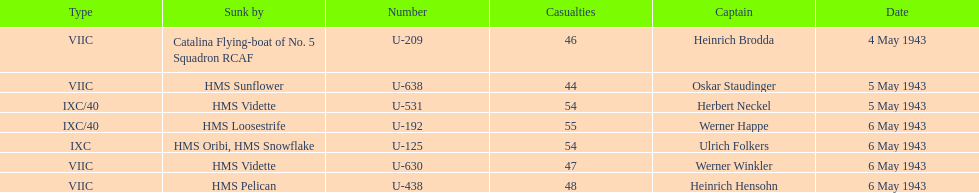Which sunken u-boat had the most casualties U-192. Could you parse the entire table? {'header': ['Type', 'Sunk by', 'Number', 'Casualties', 'Captain', 'Date'], 'rows': [['VIIC', 'Catalina Flying-boat of No. 5 Squadron RCAF', 'U-209', '46', 'Heinrich Brodda', '4 May 1943'], ['VIIC', 'HMS Sunflower', 'U-638', '44', 'Oskar Staudinger', '5 May 1943'], ['IXC/40', 'HMS Vidette', 'U-531', '54', 'Herbert Neckel', '5 May 1943'], ['IXC/40', 'HMS Loosestrife', 'U-192', '55', 'Werner Happe', '6 May 1943'], ['IXC', 'HMS Oribi, HMS Snowflake', 'U-125', '54', 'Ulrich Folkers', '6 May 1943'], ['VIIC', 'HMS Vidette', 'U-630', '47', 'Werner Winkler', '6 May 1943'], ['VIIC', 'HMS Pelican', 'U-438', '48', 'Heinrich Hensohn', '6 May 1943']]} 